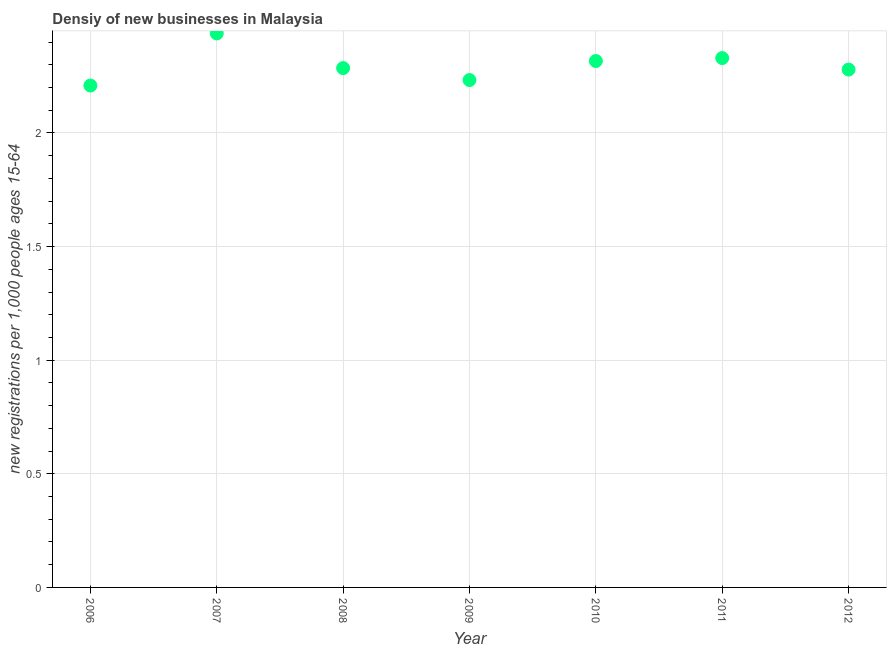What is the density of new business in 2010?
Provide a succinct answer. 2.32. Across all years, what is the maximum density of new business?
Your answer should be very brief. 2.44. Across all years, what is the minimum density of new business?
Ensure brevity in your answer.  2.21. In which year was the density of new business minimum?
Give a very brief answer. 2006. What is the sum of the density of new business?
Make the answer very short. 16.09. What is the difference between the density of new business in 2007 and 2008?
Provide a short and direct response. 0.15. What is the average density of new business per year?
Your answer should be compact. 2.3. What is the median density of new business?
Offer a very short reply. 2.29. In how many years, is the density of new business greater than 1.9 ?
Keep it short and to the point. 7. Do a majority of the years between 2010 and 2012 (inclusive) have density of new business greater than 0.6 ?
Provide a succinct answer. Yes. What is the ratio of the density of new business in 2008 to that in 2011?
Your answer should be compact. 0.98. Is the density of new business in 2011 less than that in 2012?
Your response must be concise. No. What is the difference between the highest and the second highest density of new business?
Provide a short and direct response. 0.11. What is the difference between the highest and the lowest density of new business?
Ensure brevity in your answer.  0.23. In how many years, is the density of new business greater than the average density of new business taken over all years?
Your answer should be very brief. 3. How many dotlines are there?
Provide a short and direct response. 1. Does the graph contain any zero values?
Your response must be concise. No. What is the title of the graph?
Ensure brevity in your answer.  Densiy of new businesses in Malaysia. What is the label or title of the Y-axis?
Your response must be concise. New registrations per 1,0 people ages 15-64. What is the new registrations per 1,000 people ages 15-64 in 2006?
Give a very brief answer. 2.21. What is the new registrations per 1,000 people ages 15-64 in 2007?
Make the answer very short. 2.44. What is the new registrations per 1,000 people ages 15-64 in 2008?
Make the answer very short. 2.29. What is the new registrations per 1,000 people ages 15-64 in 2009?
Make the answer very short. 2.23. What is the new registrations per 1,000 people ages 15-64 in 2010?
Your answer should be compact. 2.32. What is the new registrations per 1,000 people ages 15-64 in 2011?
Your response must be concise. 2.33. What is the new registrations per 1,000 people ages 15-64 in 2012?
Your answer should be very brief. 2.28. What is the difference between the new registrations per 1,000 people ages 15-64 in 2006 and 2007?
Keep it short and to the point. -0.23. What is the difference between the new registrations per 1,000 people ages 15-64 in 2006 and 2008?
Offer a very short reply. -0.08. What is the difference between the new registrations per 1,000 people ages 15-64 in 2006 and 2009?
Keep it short and to the point. -0.02. What is the difference between the new registrations per 1,000 people ages 15-64 in 2006 and 2010?
Provide a succinct answer. -0.11. What is the difference between the new registrations per 1,000 people ages 15-64 in 2006 and 2011?
Make the answer very short. -0.12. What is the difference between the new registrations per 1,000 people ages 15-64 in 2006 and 2012?
Make the answer very short. -0.07. What is the difference between the new registrations per 1,000 people ages 15-64 in 2007 and 2008?
Your response must be concise. 0.15. What is the difference between the new registrations per 1,000 people ages 15-64 in 2007 and 2009?
Your answer should be compact. 0.21. What is the difference between the new registrations per 1,000 people ages 15-64 in 2007 and 2010?
Your answer should be very brief. 0.12. What is the difference between the new registrations per 1,000 people ages 15-64 in 2007 and 2011?
Provide a short and direct response. 0.11. What is the difference between the new registrations per 1,000 people ages 15-64 in 2007 and 2012?
Give a very brief answer. 0.16. What is the difference between the new registrations per 1,000 people ages 15-64 in 2008 and 2009?
Offer a very short reply. 0.05. What is the difference between the new registrations per 1,000 people ages 15-64 in 2008 and 2010?
Offer a terse response. -0.03. What is the difference between the new registrations per 1,000 people ages 15-64 in 2008 and 2011?
Offer a very short reply. -0.04. What is the difference between the new registrations per 1,000 people ages 15-64 in 2008 and 2012?
Offer a very short reply. 0.01. What is the difference between the new registrations per 1,000 people ages 15-64 in 2009 and 2010?
Make the answer very short. -0.08. What is the difference between the new registrations per 1,000 people ages 15-64 in 2009 and 2011?
Provide a succinct answer. -0.1. What is the difference between the new registrations per 1,000 people ages 15-64 in 2009 and 2012?
Your response must be concise. -0.05. What is the difference between the new registrations per 1,000 people ages 15-64 in 2010 and 2011?
Offer a terse response. -0.01. What is the difference between the new registrations per 1,000 people ages 15-64 in 2010 and 2012?
Provide a short and direct response. 0.04. What is the difference between the new registrations per 1,000 people ages 15-64 in 2011 and 2012?
Your answer should be very brief. 0.05. What is the ratio of the new registrations per 1,000 people ages 15-64 in 2006 to that in 2007?
Provide a short and direct response. 0.91. What is the ratio of the new registrations per 1,000 people ages 15-64 in 2006 to that in 2008?
Your answer should be compact. 0.97. What is the ratio of the new registrations per 1,000 people ages 15-64 in 2006 to that in 2010?
Your response must be concise. 0.95. What is the ratio of the new registrations per 1,000 people ages 15-64 in 2006 to that in 2011?
Offer a very short reply. 0.95. What is the ratio of the new registrations per 1,000 people ages 15-64 in 2007 to that in 2008?
Offer a terse response. 1.07. What is the ratio of the new registrations per 1,000 people ages 15-64 in 2007 to that in 2009?
Your answer should be compact. 1.09. What is the ratio of the new registrations per 1,000 people ages 15-64 in 2007 to that in 2010?
Your answer should be compact. 1.05. What is the ratio of the new registrations per 1,000 people ages 15-64 in 2007 to that in 2011?
Make the answer very short. 1.05. What is the ratio of the new registrations per 1,000 people ages 15-64 in 2007 to that in 2012?
Your response must be concise. 1.07. What is the ratio of the new registrations per 1,000 people ages 15-64 in 2008 to that in 2012?
Offer a very short reply. 1. What is the ratio of the new registrations per 1,000 people ages 15-64 in 2009 to that in 2011?
Offer a terse response. 0.96. What is the ratio of the new registrations per 1,000 people ages 15-64 in 2009 to that in 2012?
Provide a succinct answer. 0.98. What is the ratio of the new registrations per 1,000 people ages 15-64 in 2010 to that in 2012?
Make the answer very short. 1.02. What is the ratio of the new registrations per 1,000 people ages 15-64 in 2011 to that in 2012?
Your response must be concise. 1.02. 